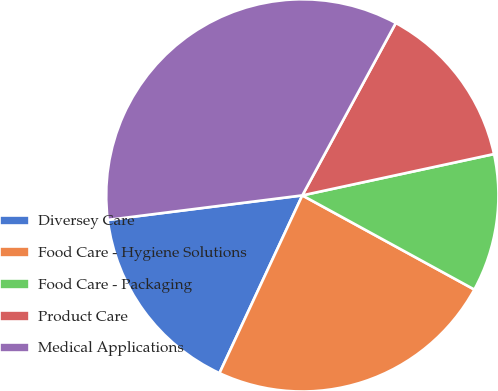Convert chart. <chart><loc_0><loc_0><loc_500><loc_500><pie_chart><fcel>Diversey Care<fcel>Food Care - Hygiene Solutions<fcel>Food Care - Packaging<fcel>Product Care<fcel>Medical Applications<nl><fcel>16.06%<fcel>23.97%<fcel>11.35%<fcel>13.71%<fcel>34.9%<nl></chart> 